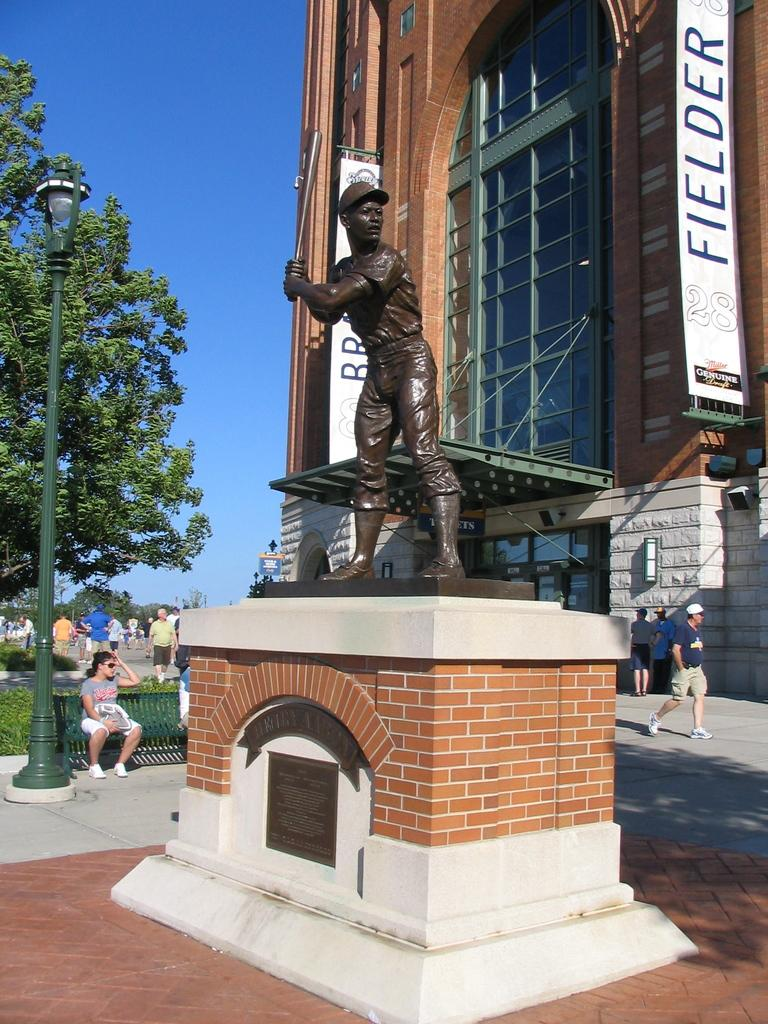Provide a one-sentence caption for the provided image. A statue of a baseball player stands in front of the stadium where the Brewers play. 